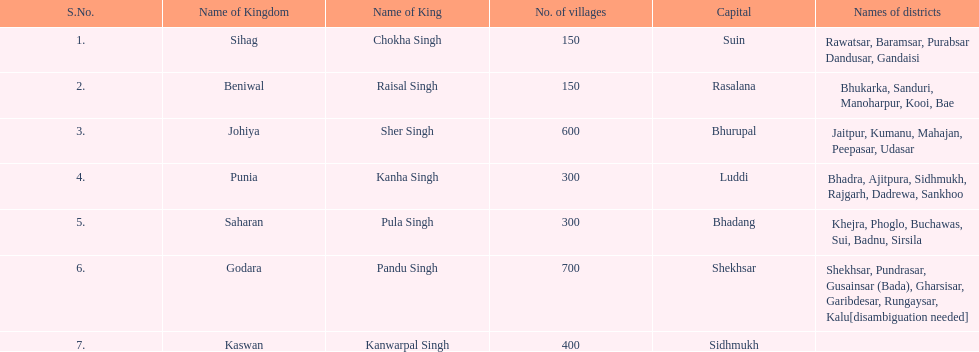Are there more or fewer villages in punia than in godara? Less. 